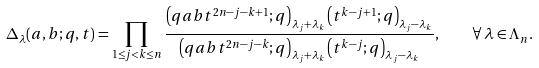<formula> <loc_0><loc_0><loc_500><loc_500>\Delta _ { \lambda } ( a , b ; q , t ) = \prod _ { 1 \leq j < k \leq n } \frac { \left ( q a b t ^ { 2 n - j - k + 1 } ; q \right ) _ { \lambda _ { j } + \lambda _ { k } } \left ( t ^ { k - j + 1 } ; q \right ) _ { \lambda _ { j } - \lambda _ { k } } } { \left ( q a b t ^ { 2 n - j - k } ; q \right ) _ { \lambda _ { j } + \lambda _ { k } } \left ( t ^ { k - j } ; q \right ) _ { \lambda _ { j } - \lambda _ { k } } } , \quad \forall \, \lambda \in \Lambda _ { n } .</formula> 